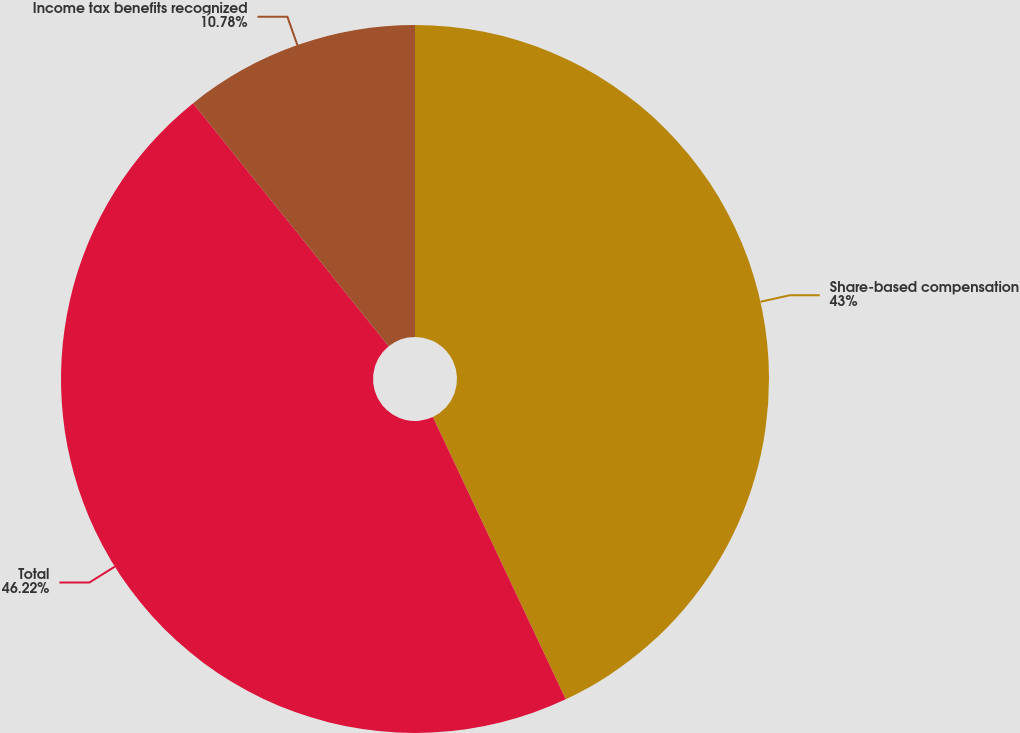Convert chart to OTSL. <chart><loc_0><loc_0><loc_500><loc_500><pie_chart><fcel>Share-based compensation<fcel>Total<fcel>Income tax benefits recognized<nl><fcel>43.0%<fcel>46.22%<fcel>10.78%<nl></chart> 